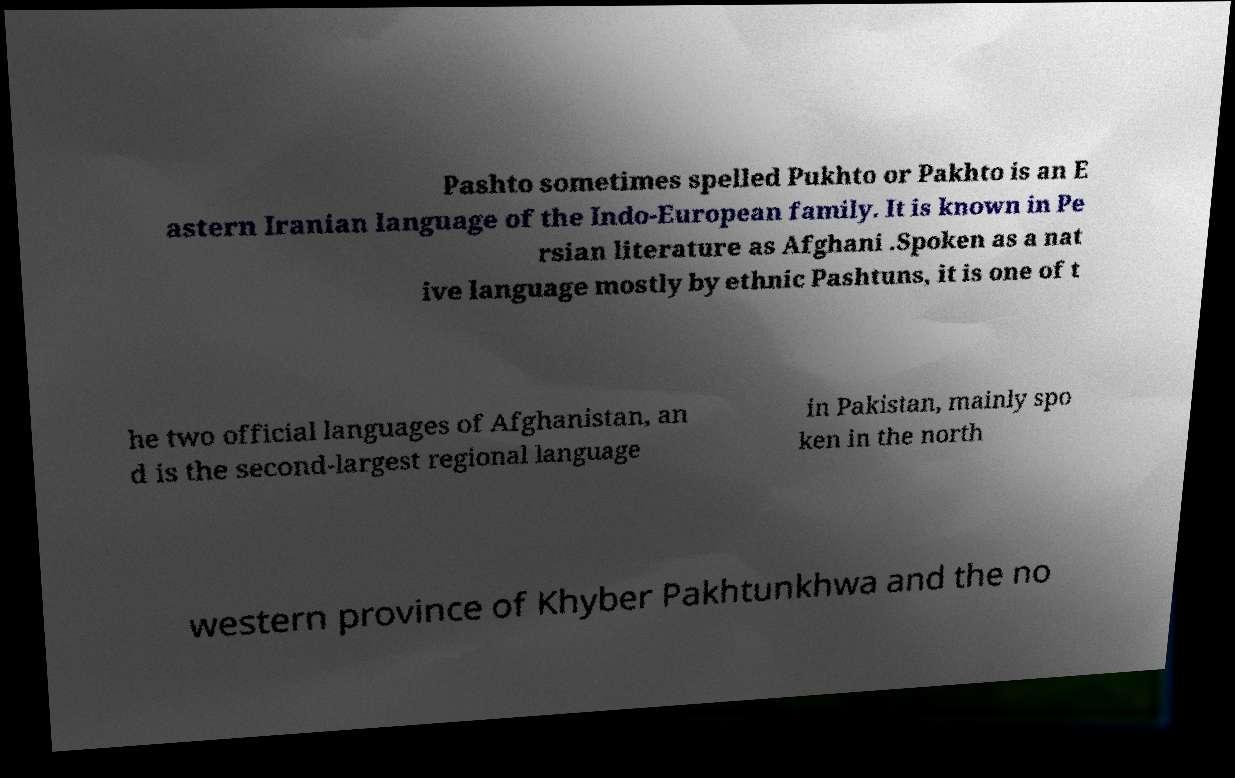Could you assist in decoding the text presented in this image and type it out clearly? Pashto sometimes spelled Pukhto or Pakhto is an E astern Iranian language of the Indo-European family. It is known in Pe rsian literature as Afghani .Spoken as a nat ive language mostly by ethnic Pashtuns, it is one of t he two official languages of Afghanistan, an d is the second-largest regional language in Pakistan, mainly spo ken in the north western province of Khyber Pakhtunkhwa and the no 